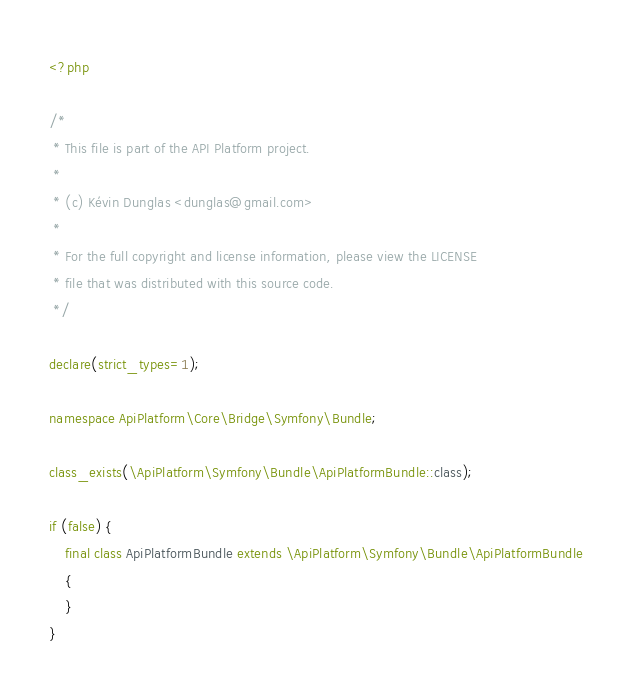Convert code to text. <code><loc_0><loc_0><loc_500><loc_500><_PHP_><?php

/*
 * This file is part of the API Platform project.
 *
 * (c) Kévin Dunglas <dunglas@gmail.com>
 *
 * For the full copyright and license information, please view the LICENSE
 * file that was distributed with this source code.
 */

declare(strict_types=1);

namespace ApiPlatform\Core\Bridge\Symfony\Bundle;

class_exists(\ApiPlatform\Symfony\Bundle\ApiPlatformBundle::class);

if (false) {
    final class ApiPlatformBundle extends \ApiPlatform\Symfony\Bundle\ApiPlatformBundle
    {
    }
}
</code> 